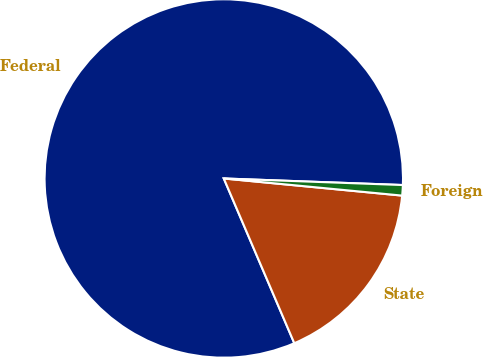<chart> <loc_0><loc_0><loc_500><loc_500><pie_chart><fcel>Federal<fcel>State<fcel>Foreign<nl><fcel>82.02%<fcel>17.04%<fcel>0.94%<nl></chart> 